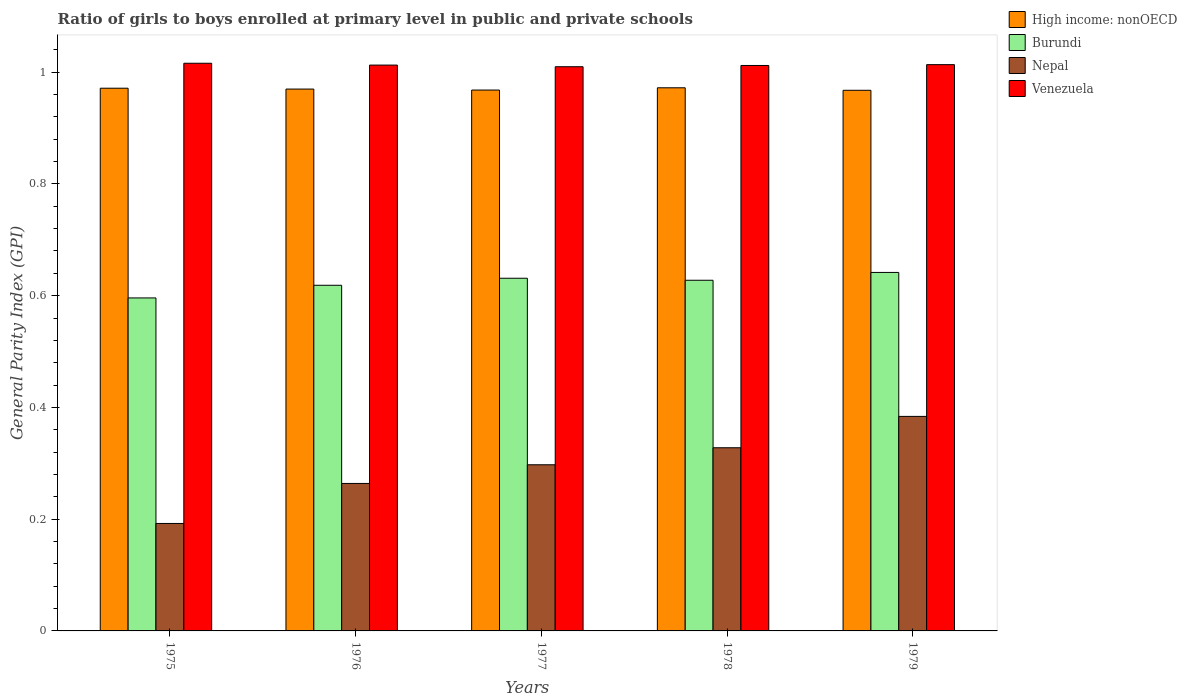How many different coloured bars are there?
Offer a terse response. 4. How many groups of bars are there?
Your answer should be compact. 5. Are the number of bars per tick equal to the number of legend labels?
Provide a short and direct response. Yes. How many bars are there on the 2nd tick from the right?
Your answer should be compact. 4. What is the label of the 4th group of bars from the left?
Provide a short and direct response. 1978. What is the general parity index in Venezuela in 1977?
Give a very brief answer. 1.01. Across all years, what is the maximum general parity index in High income: nonOECD?
Your response must be concise. 0.97. Across all years, what is the minimum general parity index in High income: nonOECD?
Your answer should be compact. 0.97. In which year was the general parity index in Nepal maximum?
Provide a short and direct response. 1979. In which year was the general parity index in Nepal minimum?
Make the answer very short. 1975. What is the total general parity index in Burundi in the graph?
Your response must be concise. 3.12. What is the difference between the general parity index in High income: nonOECD in 1975 and that in 1978?
Offer a terse response. -0. What is the difference between the general parity index in Nepal in 1978 and the general parity index in High income: nonOECD in 1979?
Provide a succinct answer. -0.64. What is the average general parity index in Burundi per year?
Provide a short and direct response. 0.62. In the year 1977, what is the difference between the general parity index in High income: nonOECD and general parity index in Nepal?
Provide a succinct answer. 0.67. What is the ratio of the general parity index in Venezuela in 1978 to that in 1979?
Give a very brief answer. 1. Is the general parity index in Nepal in 1976 less than that in 1978?
Offer a very short reply. Yes. Is the difference between the general parity index in High income: nonOECD in 1975 and 1978 greater than the difference between the general parity index in Nepal in 1975 and 1978?
Your answer should be very brief. Yes. What is the difference between the highest and the second highest general parity index in Venezuela?
Keep it short and to the point. 0. What is the difference between the highest and the lowest general parity index in Burundi?
Give a very brief answer. 0.05. In how many years, is the general parity index in High income: nonOECD greater than the average general parity index in High income: nonOECD taken over all years?
Provide a succinct answer. 3. Is the sum of the general parity index in Venezuela in 1975 and 1979 greater than the maximum general parity index in Burundi across all years?
Offer a very short reply. Yes. What does the 4th bar from the left in 1977 represents?
Give a very brief answer. Venezuela. What does the 4th bar from the right in 1979 represents?
Offer a very short reply. High income: nonOECD. Are all the bars in the graph horizontal?
Keep it short and to the point. No. How many years are there in the graph?
Ensure brevity in your answer.  5. What is the difference between two consecutive major ticks on the Y-axis?
Your answer should be very brief. 0.2. Where does the legend appear in the graph?
Your answer should be very brief. Top right. How are the legend labels stacked?
Your answer should be compact. Vertical. What is the title of the graph?
Provide a succinct answer. Ratio of girls to boys enrolled at primary level in public and private schools. What is the label or title of the X-axis?
Ensure brevity in your answer.  Years. What is the label or title of the Y-axis?
Your response must be concise. General Parity Index (GPI). What is the General Parity Index (GPI) in High income: nonOECD in 1975?
Offer a very short reply. 0.97. What is the General Parity Index (GPI) in Burundi in 1975?
Offer a terse response. 0.6. What is the General Parity Index (GPI) in Nepal in 1975?
Offer a terse response. 0.19. What is the General Parity Index (GPI) of Venezuela in 1975?
Your answer should be very brief. 1.02. What is the General Parity Index (GPI) of High income: nonOECD in 1976?
Offer a terse response. 0.97. What is the General Parity Index (GPI) in Burundi in 1976?
Offer a terse response. 0.62. What is the General Parity Index (GPI) in Nepal in 1976?
Make the answer very short. 0.26. What is the General Parity Index (GPI) in Venezuela in 1976?
Offer a terse response. 1.01. What is the General Parity Index (GPI) of High income: nonOECD in 1977?
Your answer should be very brief. 0.97. What is the General Parity Index (GPI) in Burundi in 1977?
Provide a short and direct response. 0.63. What is the General Parity Index (GPI) in Nepal in 1977?
Ensure brevity in your answer.  0.3. What is the General Parity Index (GPI) of Venezuela in 1977?
Your answer should be compact. 1.01. What is the General Parity Index (GPI) in High income: nonOECD in 1978?
Your answer should be very brief. 0.97. What is the General Parity Index (GPI) in Burundi in 1978?
Provide a succinct answer. 0.63. What is the General Parity Index (GPI) of Nepal in 1978?
Give a very brief answer. 0.33. What is the General Parity Index (GPI) in Venezuela in 1978?
Offer a very short reply. 1.01. What is the General Parity Index (GPI) in High income: nonOECD in 1979?
Keep it short and to the point. 0.97. What is the General Parity Index (GPI) in Burundi in 1979?
Ensure brevity in your answer.  0.64. What is the General Parity Index (GPI) of Nepal in 1979?
Provide a succinct answer. 0.38. What is the General Parity Index (GPI) of Venezuela in 1979?
Give a very brief answer. 1.01. Across all years, what is the maximum General Parity Index (GPI) of High income: nonOECD?
Ensure brevity in your answer.  0.97. Across all years, what is the maximum General Parity Index (GPI) of Burundi?
Your answer should be very brief. 0.64. Across all years, what is the maximum General Parity Index (GPI) of Nepal?
Your answer should be very brief. 0.38. Across all years, what is the maximum General Parity Index (GPI) of Venezuela?
Offer a terse response. 1.02. Across all years, what is the minimum General Parity Index (GPI) in High income: nonOECD?
Your answer should be very brief. 0.97. Across all years, what is the minimum General Parity Index (GPI) of Burundi?
Keep it short and to the point. 0.6. Across all years, what is the minimum General Parity Index (GPI) in Nepal?
Provide a succinct answer. 0.19. Across all years, what is the minimum General Parity Index (GPI) in Venezuela?
Offer a very short reply. 1.01. What is the total General Parity Index (GPI) in High income: nonOECD in the graph?
Offer a very short reply. 4.85. What is the total General Parity Index (GPI) in Burundi in the graph?
Your response must be concise. 3.12. What is the total General Parity Index (GPI) of Nepal in the graph?
Offer a terse response. 1.47. What is the total General Parity Index (GPI) in Venezuela in the graph?
Your response must be concise. 5.06. What is the difference between the General Parity Index (GPI) of High income: nonOECD in 1975 and that in 1976?
Keep it short and to the point. 0. What is the difference between the General Parity Index (GPI) in Burundi in 1975 and that in 1976?
Your answer should be compact. -0.02. What is the difference between the General Parity Index (GPI) of Nepal in 1975 and that in 1976?
Give a very brief answer. -0.07. What is the difference between the General Parity Index (GPI) in Venezuela in 1975 and that in 1976?
Provide a succinct answer. 0. What is the difference between the General Parity Index (GPI) in High income: nonOECD in 1975 and that in 1977?
Offer a very short reply. 0. What is the difference between the General Parity Index (GPI) in Burundi in 1975 and that in 1977?
Your response must be concise. -0.04. What is the difference between the General Parity Index (GPI) in Nepal in 1975 and that in 1977?
Your answer should be compact. -0.1. What is the difference between the General Parity Index (GPI) in Venezuela in 1975 and that in 1977?
Provide a succinct answer. 0.01. What is the difference between the General Parity Index (GPI) of High income: nonOECD in 1975 and that in 1978?
Provide a short and direct response. -0. What is the difference between the General Parity Index (GPI) in Burundi in 1975 and that in 1978?
Provide a short and direct response. -0.03. What is the difference between the General Parity Index (GPI) in Nepal in 1975 and that in 1978?
Offer a very short reply. -0.14. What is the difference between the General Parity Index (GPI) of Venezuela in 1975 and that in 1978?
Offer a terse response. 0. What is the difference between the General Parity Index (GPI) in High income: nonOECD in 1975 and that in 1979?
Give a very brief answer. 0. What is the difference between the General Parity Index (GPI) in Burundi in 1975 and that in 1979?
Ensure brevity in your answer.  -0.05. What is the difference between the General Parity Index (GPI) in Nepal in 1975 and that in 1979?
Offer a very short reply. -0.19. What is the difference between the General Parity Index (GPI) of Venezuela in 1975 and that in 1979?
Your response must be concise. 0. What is the difference between the General Parity Index (GPI) of High income: nonOECD in 1976 and that in 1977?
Ensure brevity in your answer.  0. What is the difference between the General Parity Index (GPI) of Burundi in 1976 and that in 1977?
Offer a terse response. -0.01. What is the difference between the General Parity Index (GPI) in Nepal in 1976 and that in 1977?
Provide a short and direct response. -0.03. What is the difference between the General Parity Index (GPI) in Venezuela in 1976 and that in 1977?
Your response must be concise. 0. What is the difference between the General Parity Index (GPI) in High income: nonOECD in 1976 and that in 1978?
Your answer should be very brief. -0. What is the difference between the General Parity Index (GPI) of Burundi in 1976 and that in 1978?
Ensure brevity in your answer.  -0.01. What is the difference between the General Parity Index (GPI) in Nepal in 1976 and that in 1978?
Ensure brevity in your answer.  -0.06. What is the difference between the General Parity Index (GPI) in Venezuela in 1976 and that in 1978?
Keep it short and to the point. 0. What is the difference between the General Parity Index (GPI) of High income: nonOECD in 1976 and that in 1979?
Offer a very short reply. 0. What is the difference between the General Parity Index (GPI) of Burundi in 1976 and that in 1979?
Your answer should be very brief. -0.02. What is the difference between the General Parity Index (GPI) of Nepal in 1976 and that in 1979?
Give a very brief answer. -0.12. What is the difference between the General Parity Index (GPI) in Venezuela in 1976 and that in 1979?
Your response must be concise. -0. What is the difference between the General Parity Index (GPI) of High income: nonOECD in 1977 and that in 1978?
Provide a short and direct response. -0. What is the difference between the General Parity Index (GPI) of Burundi in 1977 and that in 1978?
Ensure brevity in your answer.  0. What is the difference between the General Parity Index (GPI) in Nepal in 1977 and that in 1978?
Your answer should be compact. -0.03. What is the difference between the General Parity Index (GPI) of Venezuela in 1977 and that in 1978?
Offer a very short reply. -0. What is the difference between the General Parity Index (GPI) of High income: nonOECD in 1977 and that in 1979?
Ensure brevity in your answer.  0. What is the difference between the General Parity Index (GPI) of Burundi in 1977 and that in 1979?
Offer a terse response. -0.01. What is the difference between the General Parity Index (GPI) of Nepal in 1977 and that in 1979?
Your answer should be very brief. -0.09. What is the difference between the General Parity Index (GPI) of Venezuela in 1977 and that in 1979?
Ensure brevity in your answer.  -0. What is the difference between the General Parity Index (GPI) of High income: nonOECD in 1978 and that in 1979?
Give a very brief answer. 0. What is the difference between the General Parity Index (GPI) of Burundi in 1978 and that in 1979?
Make the answer very short. -0.01. What is the difference between the General Parity Index (GPI) in Nepal in 1978 and that in 1979?
Offer a terse response. -0.06. What is the difference between the General Parity Index (GPI) in Venezuela in 1978 and that in 1979?
Offer a terse response. -0. What is the difference between the General Parity Index (GPI) in High income: nonOECD in 1975 and the General Parity Index (GPI) in Burundi in 1976?
Make the answer very short. 0.35. What is the difference between the General Parity Index (GPI) of High income: nonOECD in 1975 and the General Parity Index (GPI) of Nepal in 1976?
Keep it short and to the point. 0.71. What is the difference between the General Parity Index (GPI) in High income: nonOECD in 1975 and the General Parity Index (GPI) in Venezuela in 1976?
Give a very brief answer. -0.04. What is the difference between the General Parity Index (GPI) in Burundi in 1975 and the General Parity Index (GPI) in Nepal in 1976?
Your response must be concise. 0.33. What is the difference between the General Parity Index (GPI) in Burundi in 1975 and the General Parity Index (GPI) in Venezuela in 1976?
Provide a short and direct response. -0.42. What is the difference between the General Parity Index (GPI) of Nepal in 1975 and the General Parity Index (GPI) of Venezuela in 1976?
Ensure brevity in your answer.  -0.82. What is the difference between the General Parity Index (GPI) of High income: nonOECD in 1975 and the General Parity Index (GPI) of Burundi in 1977?
Provide a short and direct response. 0.34. What is the difference between the General Parity Index (GPI) of High income: nonOECD in 1975 and the General Parity Index (GPI) of Nepal in 1977?
Offer a very short reply. 0.67. What is the difference between the General Parity Index (GPI) in High income: nonOECD in 1975 and the General Parity Index (GPI) in Venezuela in 1977?
Offer a terse response. -0.04. What is the difference between the General Parity Index (GPI) of Burundi in 1975 and the General Parity Index (GPI) of Nepal in 1977?
Ensure brevity in your answer.  0.3. What is the difference between the General Parity Index (GPI) in Burundi in 1975 and the General Parity Index (GPI) in Venezuela in 1977?
Your answer should be very brief. -0.41. What is the difference between the General Parity Index (GPI) in Nepal in 1975 and the General Parity Index (GPI) in Venezuela in 1977?
Your response must be concise. -0.82. What is the difference between the General Parity Index (GPI) in High income: nonOECD in 1975 and the General Parity Index (GPI) in Burundi in 1978?
Provide a short and direct response. 0.34. What is the difference between the General Parity Index (GPI) of High income: nonOECD in 1975 and the General Parity Index (GPI) of Nepal in 1978?
Ensure brevity in your answer.  0.64. What is the difference between the General Parity Index (GPI) of High income: nonOECD in 1975 and the General Parity Index (GPI) of Venezuela in 1978?
Provide a succinct answer. -0.04. What is the difference between the General Parity Index (GPI) of Burundi in 1975 and the General Parity Index (GPI) of Nepal in 1978?
Provide a short and direct response. 0.27. What is the difference between the General Parity Index (GPI) of Burundi in 1975 and the General Parity Index (GPI) of Venezuela in 1978?
Make the answer very short. -0.42. What is the difference between the General Parity Index (GPI) in Nepal in 1975 and the General Parity Index (GPI) in Venezuela in 1978?
Offer a very short reply. -0.82. What is the difference between the General Parity Index (GPI) of High income: nonOECD in 1975 and the General Parity Index (GPI) of Burundi in 1979?
Give a very brief answer. 0.33. What is the difference between the General Parity Index (GPI) in High income: nonOECD in 1975 and the General Parity Index (GPI) in Nepal in 1979?
Ensure brevity in your answer.  0.59. What is the difference between the General Parity Index (GPI) of High income: nonOECD in 1975 and the General Parity Index (GPI) of Venezuela in 1979?
Ensure brevity in your answer.  -0.04. What is the difference between the General Parity Index (GPI) of Burundi in 1975 and the General Parity Index (GPI) of Nepal in 1979?
Make the answer very short. 0.21. What is the difference between the General Parity Index (GPI) of Burundi in 1975 and the General Parity Index (GPI) of Venezuela in 1979?
Provide a succinct answer. -0.42. What is the difference between the General Parity Index (GPI) in Nepal in 1975 and the General Parity Index (GPI) in Venezuela in 1979?
Keep it short and to the point. -0.82. What is the difference between the General Parity Index (GPI) in High income: nonOECD in 1976 and the General Parity Index (GPI) in Burundi in 1977?
Ensure brevity in your answer.  0.34. What is the difference between the General Parity Index (GPI) in High income: nonOECD in 1976 and the General Parity Index (GPI) in Nepal in 1977?
Keep it short and to the point. 0.67. What is the difference between the General Parity Index (GPI) in High income: nonOECD in 1976 and the General Parity Index (GPI) in Venezuela in 1977?
Offer a terse response. -0.04. What is the difference between the General Parity Index (GPI) of Burundi in 1976 and the General Parity Index (GPI) of Nepal in 1977?
Provide a succinct answer. 0.32. What is the difference between the General Parity Index (GPI) in Burundi in 1976 and the General Parity Index (GPI) in Venezuela in 1977?
Your answer should be very brief. -0.39. What is the difference between the General Parity Index (GPI) in Nepal in 1976 and the General Parity Index (GPI) in Venezuela in 1977?
Provide a succinct answer. -0.75. What is the difference between the General Parity Index (GPI) of High income: nonOECD in 1976 and the General Parity Index (GPI) of Burundi in 1978?
Provide a succinct answer. 0.34. What is the difference between the General Parity Index (GPI) of High income: nonOECD in 1976 and the General Parity Index (GPI) of Nepal in 1978?
Make the answer very short. 0.64. What is the difference between the General Parity Index (GPI) of High income: nonOECD in 1976 and the General Parity Index (GPI) of Venezuela in 1978?
Offer a very short reply. -0.04. What is the difference between the General Parity Index (GPI) in Burundi in 1976 and the General Parity Index (GPI) in Nepal in 1978?
Make the answer very short. 0.29. What is the difference between the General Parity Index (GPI) of Burundi in 1976 and the General Parity Index (GPI) of Venezuela in 1978?
Your response must be concise. -0.39. What is the difference between the General Parity Index (GPI) of Nepal in 1976 and the General Parity Index (GPI) of Venezuela in 1978?
Offer a very short reply. -0.75. What is the difference between the General Parity Index (GPI) in High income: nonOECD in 1976 and the General Parity Index (GPI) in Burundi in 1979?
Give a very brief answer. 0.33. What is the difference between the General Parity Index (GPI) in High income: nonOECD in 1976 and the General Parity Index (GPI) in Nepal in 1979?
Keep it short and to the point. 0.59. What is the difference between the General Parity Index (GPI) in High income: nonOECD in 1976 and the General Parity Index (GPI) in Venezuela in 1979?
Provide a short and direct response. -0.04. What is the difference between the General Parity Index (GPI) in Burundi in 1976 and the General Parity Index (GPI) in Nepal in 1979?
Offer a very short reply. 0.23. What is the difference between the General Parity Index (GPI) in Burundi in 1976 and the General Parity Index (GPI) in Venezuela in 1979?
Offer a very short reply. -0.39. What is the difference between the General Parity Index (GPI) of Nepal in 1976 and the General Parity Index (GPI) of Venezuela in 1979?
Your response must be concise. -0.75. What is the difference between the General Parity Index (GPI) in High income: nonOECD in 1977 and the General Parity Index (GPI) in Burundi in 1978?
Your response must be concise. 0.34. What is the difference between the General Parity Index (GPI) of High income: nonOECD in 1977 and the General Parity Index (GPI) of Nepal in 1978?
Provide a succinct answer. 0.64. What is the difference between the General Parity Index (GPI) in High income: nonOECD in 1977 and the General Parity Index (GPI) in Venezuela in 1978?
Give a very brief answer. -0.04. What is the difference between the General Parity Index (GPI) in Burundi in 1977 and the General Parity Index (GPI) in Nepal in 1978?
Keep it short and to the point. 0.3. What is the difference between the General Parity Index (GPI) in Burundi in 1977 and the General Parity Index (GPI) in Venezuela in 1978?
Your response must be concise. -0.38. What is the difference between the General Parity Index (GPI) in Nepal in 1977 and the General Parity Index (GPI) in Venezuela in 1978?
Ensure brevity in your answer.  -0.71. What is the difference between the General Parity Index (GPI) of High income: nonOECD in 1977 and the General Parity Index (GPI) of Burundi in 1979?
Offer a terse response. 0.33. What is the difference between the General Parity Index (GPI) of High income: nonOECD in 1977 and the General Parity Index (GPI) of Nepal in 1979?
Your answer should be very brief. 0.58. What is the difference between the General Parity Index (GPI) in High income: nonOECD in 1977 and the General Parity Index (GPI) in Venezuela in 1979?
Your answer should be very brief. -0.05. What is the difference between the General Parity Index (GPI) of Burundi in 1977 and the General Parity Index (GPI) of Nepal in 1979?
Offer a very short reply. 0.25. What is the difference between the General Parity Index (GPI) in Burundi in 1977 and the General Parity Index (GPI) in Venezuela in 1979?
Your answer should be very brief. -0.38. What is the difference between the General Parity Index (GPI) of Nepal in 1977 and the General Parity Index (GPI) of Venezuela in 1979?
Your answer should be compact. -0.72. What is the difference between the General Parity Index (GPI) of High income: nonOECD in 1978 and the General Parity Index (GPI) of Burundi in 1979?
Your response must be concise. 0.33. What is the difference between the General Parity Index (GPI) of High income: nonOECD in 1978 and the General Parity Index (GPI) of Nepal in 1979?
Ensure brevity in your answer.  0.59. What is the difference between the General Parity Index (GPI) of High income: nonOECD in 1978 and the General Parity Index (GPI) of Venezuela in 1979?
Your answer should be very brief. -0.04. What is the difference between the General Parity Index (GPI) of Burundi in 1978 and the General Parity Index (GPI) of Nepal in 1979?
Make the answer very short. 0.24. What is the difference between the General Parity Index (GPI) in Burundi in 1978 and the General Parity Index (GPI) in Venezuela in 1979?
Provide a succinct answer. -0.39. What is the difference between the General Parity Index (GPI) in Nepal in 1978 and the General Parity Index (GPI) in Venezuela in 1979?
Give a very brief answer. -0.69. What is the average General Parity Index (GPI) of High income: nonOECD per year?
Provide a succinct answer. 0.97. What is the average General Parity Index (GPI) of Burundi per year?
Your answer should be compact. 0.62. What is the average General Parity Index (GPI) of Nepal per year?
Ensure brevity in your answer.  0.29. What is the average General Parity Index (GPI) in Venezuela per year?
Your answer should be very brief. 1.01. In the year 1975, what is the difference between the General Parity Index (GPI) in High income: nonOECD and General Parity Index (GPI) in Burundi?
Make the answer very short. 0.38. In the year 1975, what is the difference between the General Parity Index (GPI) of High income: nonOECD and General Parity Index (GPI) of Nepal?
Your response must be concise. 0.78. In the year 1975, what is the difference between the General Parity Index (GPI) in High income: nonOECD and General Parity Index (GPI) in Venezuela?
Give a very brief answer. -0.04. In the year 1975, what is the difference between the General Parity Index (GPI) of Burundi and General Parity Index (GPI) of Nepal?
Offer a very short reply. 0.4. In the year 1975, what is the difference between the General Parity Index (GPI) in Burundi and General Parity Index (GPI) in Venezuela?
Give a very brief answer. -0.42. In the year 1975, what is the difference between the General Parity Index (GPI) of Nepal and General Parity Index (GPI) of Venezuela?
Make the answer very short. -0.82. In the year 1976, what is the difference between the General Parity Index (GPI) in High income: nonOECD and General Parity Index (GPI) in Burundi?
Offer a terse response. 0.35. In the year 1976, what is the difference between the General Parity Index (GPI) of High income: nonOECD and General Parity Index (GPI) of Nepal?
Your answer should be very brief. 0.71. In the year 1976, what is the difference between the General Parity Index (GPI) in High income: nonOECD and General Parity Index (GPI) in Venezuela?
Your response must be concise. -0.04. In the year 1976, what is the difference between the General Parity Index (GPI) of Burundi and General Parity Index (GPI) of Nepal?
Provide a short and direct response. 0.35. In the year 1976, what is the difference between the General Parity Index (GPI) in Burundi and General Parity Index (GPI) in Venezuela?
Your response must be concise. -0.39. In the year 1976, what is the difference between the General Parity Index (GPI) in Nepal and General Parity Index (GPI) in Venezuela?
Offer a terse response. -0.75. In the year 1977, what is the difference between the General Parity Index (GPI) of High income: nonOECD and General Parity Index (GPI) of Burundi?
Offer a very short reply. 0.34. In the year 1977, what is the difference between the General Parity Index (GPI) in High income: nonOECD and General Parity Index (GPI) in Nepal?
Make the answer very short. 0.67. In the year 1977, what is the difference between the General Parity Index (GPI) of High income: nonOECD and General Parity Index (GPI) of Venezuela?
Keep it short and to the point. -0.04. In the year 1977, what is the difference between the General Parity Index (GPI) in Burundi and General Parity Index (GPI) in Nepal?
Offer a terse response. 0.33. In the year 1977, what is the difference between the General Parity Index (GPI) in Burundi and General Parity Index (GPI) in Venezuela?
Offer a terse response. -0.38. In the year 1977, what is the difference between the General Parity Index (GPI) in Nepal and General Parity Index (GPI) in Venezuela?
Your response must be concise. -0.71. In the year 1978, what is the difference between the General Parity Index (GPI) of High income: nonOECD and General Parity Index (GPI) of Burundi?
Give a very brief answer. 0.34. In the year 1978, what is the difference between the General Parity Index (GPI) in High income: nonOECD and General Parity Index (GPI) in Nepal?
Provide a short and direct response. 0.64. In the year 1978, what is the difference between the General Parity Index (GPI) in High income: nonOECD and General Parity Index (GPI) in Venezuela?
Your answer should be compact. -0.04. In the year 1978, what is the difference between the General Parity Index (GPI) of Burundi and General Parity Index (GPI) of Nepal?
Make the answer very short. 0.3. In the year 1978, what is the difference between the General Parity Index (GPI) in Burundi and General Parity Index (GPI) in Venezuela?
Your answer should be compact. -0.38. In the year 1978, what is the difference between the General Parity Index (GPI) in Nepal and General Parity Index (GPI) in Venezuela?
Ensure brevity in your answer.  -0.68. In the year 1979, what is the difference between the General Parity Index (GPI) of High income: nonOECD and General Parity Index (GPI) of Burundi?
Provide a short and direct response. 0.33. In the year 1979, what is the difference between the General Parity Index (GPI) in High income: nonOECD and General Parity Index (GPI) in Nepal?
Ensure brevity in your answer.  0.58. In the year 1979, what is the difference between the General Parity Index (GPI) in High income: nonOECD and General Parity Index (GPI) in Venezuela?
Your response must be concise. -0.05. In the year 1979, what is the difference between the General Parity Index (GPI) of Burundi and General Parity Index (GPI) of Nepal?
Ensure brevity in your answer.  0.26. In the year 1979, what is the difference between the General Parity Index (GPI) in Burundi and General Parity Index (GPI) in Venezuela?
Your answer should be very brief. -0.37. In the year 1979, what is the difference between the General Parity Index (GPI) of Nepal and General Parity Index (GPI) of Venezuela?
Your response must be concise. -0.63. What is the ratio of the General Parity Index (GPI) of Burundi in 1975 to that in 1976?
Your answer should be compact. 0.96. What is the ratio of the General Parity Index (GPI) in Nepal in 1975 to that in 1976?
Keep it short and to the point. 0.73. What is the ratio of the General Parity Index (GPI) of Burundi in 1975 to that in 1977?
Offer a very short reply. 0.94. What is the ratio of the General Parity Index (GPI) of Nepal in 1975 to that in 1977?
Offer a very short reply. 0.65. What is the ratio of the General Parity Index (GPI) in High income: nonOECD in 1975 to that in 1978?
Your response must be concise. 1. What is the ratio of the General Parity Index (GPI) of Burundi in 1975 to that in 1978?
Offer a very short reply. 0.95. What is the ratio of the General Parity Index (GPI) in Nepal in 1975 to that in 1978?
Keep it short and to the point. 0.59. What is the ratio of the General Parity Index (GPI) of Venezuela in 1975 to that in 1978?
Give a very brief answer. 1. What is the ratio of the General Parity Index (GPI) of High income: nonOECD in 1975 to that in 1979?
Your response must be concise. 1. What is the ratio of the General Parity Index (GPI) of Burundi in 1975 to that in 1979?
Your answer should be very brief. 0.93. What is the ratio of the General Parity Index (GPI) of Nepal in 1975 to that in 1979?
Offer a very short reply. 0.5. What is the ratio of the General Parity Index (GPI) of Venezuela in 1975 to that in 1979?
Offer a terse response. 1. What is the ratio of the General Parity Index (GPI) of Burundi in 1976 to that in 1977?
Provide a short and direct response. 0.98. What is the ratio of the General Parity Index (GPI) in Nepal in 1976 to that in 1977?
Your answer should be very brief. 0.89. What is the ratio of the General Parity Index (GPI) in Venezuela in 1976 to that in 1977?
Make the answer very short. 1. What is the ratio of the General Parity Index (GPI) of High income: nonOECD in 1976 to that in 1978?
Make the answer very short. 1. What is the ratio of the General Parity Index (GPI) in Burundi in 1976 to that in 1978?
Provide a succinct answer. 0.99. What is the ratio of the General Parity Index (GPI) of Nepal in 1976 to that in 1978?
Your answer should be compact. 0.81. What is the ratio of the General Parity Index (GPI) in High income: nonOECD in 1976 to that in 1979?
Your response must be concise. 1. What is the ratio of the General Parity Index (GPI) in Burundi in 1976 to that in 1979?
Offer a terse response. 0.96. What is the ratio of the General Parity Index (GPI) in Nepal in 1976 to that in 1979?
Your response must be concise. 0.69. What is the ratio of the General Parity Index (GPI) of Venezuela in 1976 to that in 1979?
Offer a very short reply. 1. What is the ratio of the General Parity Index (GPI) in Burundi in 1977 to that in 1978?
Your answer should be very brief. 1.01. What is the ratio of the General Parity Index (GPI) of Nepal in 1977 to that in 1978?
Ensure brevity in your answer.  0.91. What is the ratio of the General Parity Index (GPI) in Venezuela in 1977 to that in 1978?
Make the answer very short. 1. What is the ratio of the General Parity Index (GPI) of Burundi in 1977 to that in 1979?
Your answer should be compact. 0.98. What is the ratio of the General Parity Index (GPI) of Nepal in 1977 to that in 1979?
Provide a succinct answer. 0.77. What is the ratio of the General Parity Index (GPI) in Venezuela in 1977 to that in 1979?
Give a very brief answer. 1. What is the ratio of the General Parity Index (GPI) in Burundi in 1978 to that in 1979?
Keep it short and to the point. 0.98. What is the ratio of the General Parity Index (GPI) of Nepal in 1978 to that in 1979?
Your answer should be compact. 0.85. What is the difference between the highest and the second highest General Parity Index (GPI) in High income: nonOECD?
Your response must be concise. 0. What is the difference between the highest and the second highest General Parity Index (GPI) of Burundi?
Keep it short and to the point. 0.01. What is the difference between the highest and the second highest General Parity Index (GPI) of Nepal?
Your answer should be compact. 0.06. What is the difference between the highest and the second highest General Parity Index (GPI) of Venezuela?
Your answer should be compact. 0. What is the difference between the highest and the lowest General Parity Index (GPI) of High income: nonOECD?
Provide a short and direct response. 0. What is the difference between the highest and the lowest General Parity Index (GPI) of Burundi?
Your response must be concise. 0.05. What is the difference between the highest and the lowest General Parity Index (GPI) in Nepal?
Offer a very short reply. 0.19. What is the difference between the highest and the lowest General Parity Index (GPI) in Venezuela?
Offer a terse response. 0.01. 